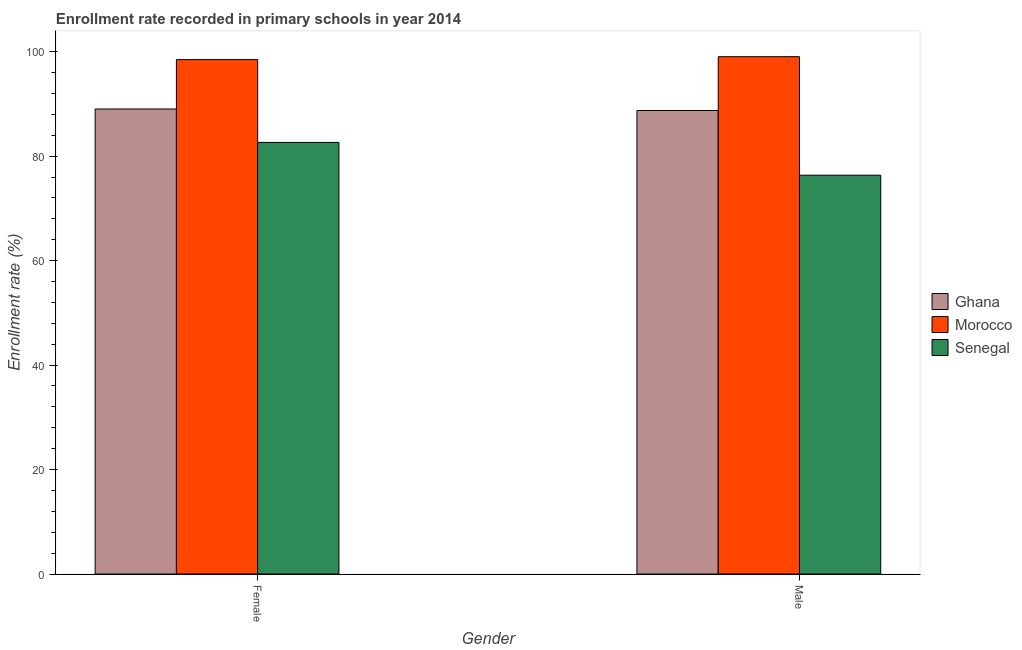How many different coloured bars are there?
Offer a terse response. 3. How many bars are there on the 1st tick from the left?
Your response must be concise. 3. How many bars are there on the 1st tick from the right?
Give a very brief answer. 3. What is the enrollment rate of female students in Senegal?
Provide a short and direct response. 82.63. Across all countries, what is the maximum enrollment rate of male students?
Your answer should be very brief. 99.03. Across all countries, what is the minimum enrollment rate of female students?
Provide a short and direct response. 82.63. In which country was the enrollment rate of male students maximum?
Your answer should be very brief. Morocco. In which country was the enrollment rate of female students minimum?
Offer a very short reply. Senegal. What is the total enrollment rate of female students in the graph?
Offer a very short reply. 270.13. What is the difference between the enrollment rate of male students in Morocco and that in Senegal?
Make the answer very short. 22.69. What is the difference between the enrollment rate of male students in Ghana and the enrollment rate of female students in Senegal?
Offer a terse response. 6.11. What is the average enrollment rate of male students per country?
Provide a short and direct response. 88.04. What is the difference between the enrollment rate of female students and enrollment rate of male students in Morocco?
Your answer should be very brief. -0.55. What is the ratio of the enrollment rate of female students in Senegal to that in Morocco?
Provide a succinct answer. 0.84. In how many countries, is the enrollment rate of male students greater than the average enrollment rate of male students taken over all countries?
Ensure brevity in your answer.  2. What does the 2nd bar from the left in Female represents?
Offer a very short reply. Morocco. What does the 1st bar from the right in Male represents?
Ensure brevity in your answer.  Senegal. What is the difference between two consecutive major ticks on the Y-axis?
Give a very brief answer. 20. Does the graph contain any zero values?
Offer a terse response. No. Does the graph contain grids?
Your response must be concise. No. How are the legend labels stacked?
Give a very brief answer. Vertical. What is the title of the graph?
Your answer should be compact. Enrollment rate recorded in primary schools in year 2014. What is the label or title of the Y-axis?
Provide a short and direct response. Enrollment rate (%). What is the Enrollment rate (%) in Ghana in Female?
Ensure brevity in your answer.  89.03. What is the Enrollment rate (%) in Morocco in Female?
Your response must be concise. 98.48. What is the Enrollment rate (%) of Senegal in Female?
Your answer should be very brief. 82.63. What is the Enrollment rate (%) of Ghana in Male?
Offer a terse response. 88.73. What is the Enrollment rate (%) in Morocco in Male?
Give a very brief answer. 99.03. What is the Enrollment rate (%) of Senegal in Male?
Provide a succinct answer. 76.34. Across all Gender, what is the maximum Enrollment rate (%) of Ghana?
Offer a terse response. 89.03. Across all Gender, what is the maximum Enrollment rate (%) of Morocco?
Ensure brevity in your answer.  99.03. Across all Gender, what is the maximum Enrollment rate (%) of Senegal?
Offer a terse response. 82.63. Across all Gender, what is the minimum Enrollment rate (%) in Ghana?
Provide a short and direct response. 88.73. Across all Gender, what is the minimum Enrollment rate (%) of Morocco?
Provide a succinct answer. 98.48. Across all Gender, what is the minimum Enrollment rate (%) of Senegal?
Provide a short and direct response. 76.34. What is the total Enrollment rate (%) of Ghana in the graph?
Provide a succinct answer. 177.76. What is the total Enrollment rate (%) in Morocco in the graph?
Provide a succinct answer. 197.51. What is the total Enrollment rate (%) in Senegal in the graph?
Offer a very short reply. 158.97. What is the difference between the Enrollment rate (%) in Ghana in Female and that in Male?
Offer a very short reply. 0.29. What is the difference between the Enrollment rate (%) in Morocco in Female and that in Male?
Ensure brevity in your answer.  -0.55. What is the difference between the Enrollment rate (%) of Senegal in Female and that in Male?
Keep it short and to the point. 6.28. What is the difference between the Enrollment rate (%) in Ghana in Female and the Enrollment rate (%) in Morocco in Male?
Your response must be concise. -10.01. What is the difference between the Enrollment rate (%) of Ghana in Female and the Enrollment rate (%) of Senegal in Male?
Offer a very short reply. 12.68. What is the difference between the Enrollment rate (%) of Morocco in Female and the Enrollment rate (%) of Senegal in Male?
Your answer should be very brief. 22.14. What is the average Enrollment rate (%) of Ghana per Gender?
Your answer should be very brief. 88.88. What is the average Enrollment rate (%) in Morocco per Gender?
Your response must be concise. 98.76. What is the average Enrollment rate (%) of Senegal per Gender?
Your answer should be very brief. 79.48. What is the difference between the Enrollment rate (%) of Ghana and Enrollment rate (%) of Morocco in Female?
Ensure brevity in your answer.  -9.46. What is the difference between the Enrollment rate (%) of Ghana and Enrollment rate (%) of Senegal in Female?
Your answer should be compact. 6.4. What is the difference between the Enrollment rate (%) of Morocco and Enrollment rate (%) of Senegal in Female?
Your response must be concise. 15.86. What is the difference between the Enrollment rate (%) of Ghana and Enrollment rate (%) of Morocco in Male?
Your answer should be compact. -10.3. What is the difference between the Enrollment rate (%) in Ghana and Enrollment rate (%) in Senegal in Male?
Your answer should be very brief. 12.39. What is the difference between the Enrollment rate (%) of Morocco and Enrollment rate (%) of Senegal in Male?
Make the answer very short. 22.69. What is the ratio of the Enrollment rate (%) in Morocco in Female to that in Male?
Provide a succinct answer. 0.99. What is the ratio of the Enrollment rate (%) of Senegal in Female to that in Male?
Provide a short and direct response. 1.08. What is the difference between the highest and the second highest Enrollment rate (%) in Ghana?
Offer a terse response. 0.29. What is the difference between the highest and the second highest Enrollment rate (%) in Morocco?
Make the answer very short. 0.55. What is the difference between the highest and the second highest Enrollment rate (%) of Senegal?
Make the answer very short. 6.28. What is the difference between the highest and the lowest Enrollment rate (%) in Ghana?
Your answer should be compact. 0.29. What is the difference between the highest and the lowest Enrollment rate (%) of Morocco?
Your answer should be compact. 0.55. What is the difference between the highest and the lowest Enrollment rate (%) in Senegal?
Offer a terse response. 6.28. 